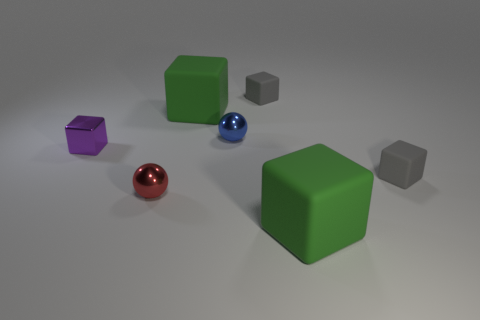Subtract all gray rubber cubes. How many cubes are left? 3 Subtract all purple cubes. How many cubes are left? 4 Add 2 small shiny balls. How many objects exist? 9 Subtract all cubes. How many objects are left? 2 Subtract all large green rubber cubes. Subtract all tiny red objects. How many objects are left? 4 Add 5 tiny red spheres. How many tiny red spheres are left? 6 Add 6 small purple cubes. How many small purple cubes exist? 7 Subtract 0 cyan balls. How many objects are left? 7 Subtract all red blocks. Subtract all brown spheres. How many blocks are left? 5 Subtract all yellow spheres. How many red cubes are left? 0 